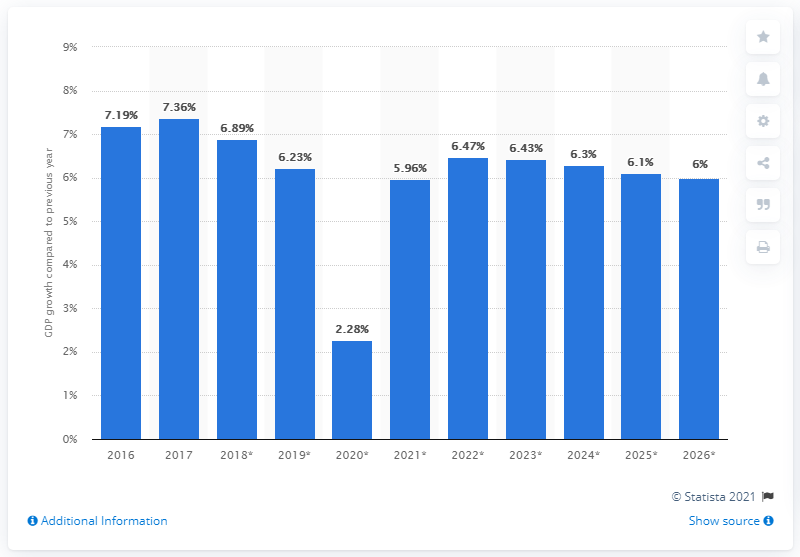Specify some key components in this picture. In 2017, Ivory Coast's real GDP grew by 7.36%. 